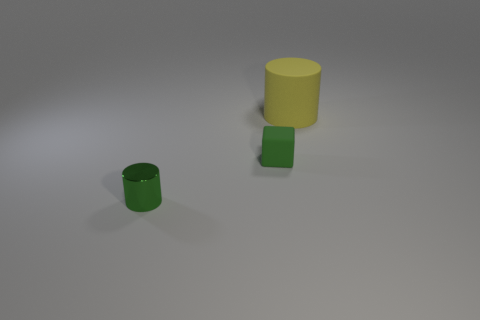There is a thing that is in front of the small cube; is its shape the same as the big yellow object behind the green shiny cylinder?
Offer a very short reply. Yes. There is a yellow matte object that is the same shape as the tiny green shiny object; what is its size?
Ensure brevity in your answer.  Large. How many tiny metallic things are the same color as the large matte cylinder?
Your answer should be very brief. 0. What is the color of the big rubber cylinder?
Your answer should be compact. Yellow. There is a object behind the tiny green matte thing; what number of yellow matte cylinders are behind it?
Offer a very short reply. 0. There is a metal cylinder; is it the same size as the matte thing that is in front of the yellow matte thing?
Give a very brief answer. Yes. Does the matte cube have the same size as the metal cylinder?
Offer a terse response. Yes. Is there a green matte thing that has the same size as the metallic cylinder?
Provide a succinct answer. Yes. What is the green thing that is behind the small shiny object made of?
Give a very brief answer. Rubber. There is a small object that is the same material as the big yellow cylinder; what is its color?
Give a very brief answer. Green. 